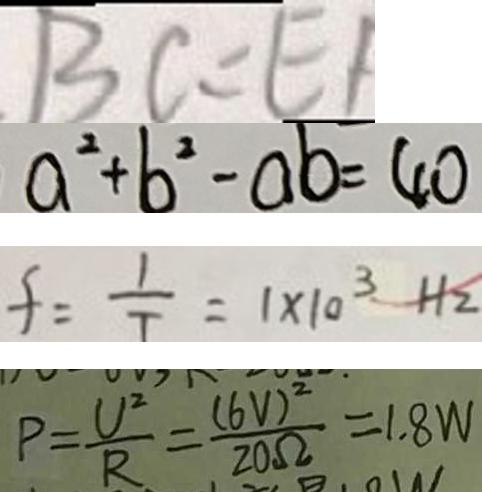<formula> <loc_0><loc_0><loc_500><loc_500>B C = E F 
 a ^ { 2 } + b ^ { 2 } - a b = 4 0 
 f = \frac { 1 } { T } = 1 \times 1 0 ^ { 3 } H z 
 P = \frac { U ^ { 2 } } { R } = \frac { ( 6 V ) ^ { 2 } } { 2 0 \Omega } = 1 . 8 W</formula> 